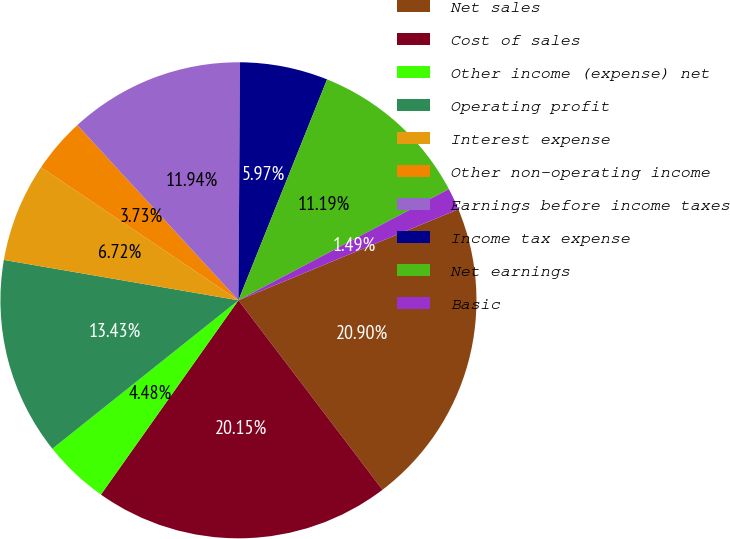<chart> <loc_0><loc_0><loc_500><loc_500><pie_chart><fcel>Net sales<fcel>Cost of sales<fcel>Other income (expense) net<fcel>Operating profit<fcel>Interest expense<fcel>Other non-operating income<fcel>Earnings before income taxes<fcel>Income tax expense<fcel>Net earnings<fcel>Basic<nl><fcel>20.9%<fcel>20.15%<fcel>4.48%<fcel>13.43%<fcel>6.72%<fcel>3.73%<fcel>11.94%<fcel>5.97%<fcel>11.19%<fcel>1.49%<nl></chart> 